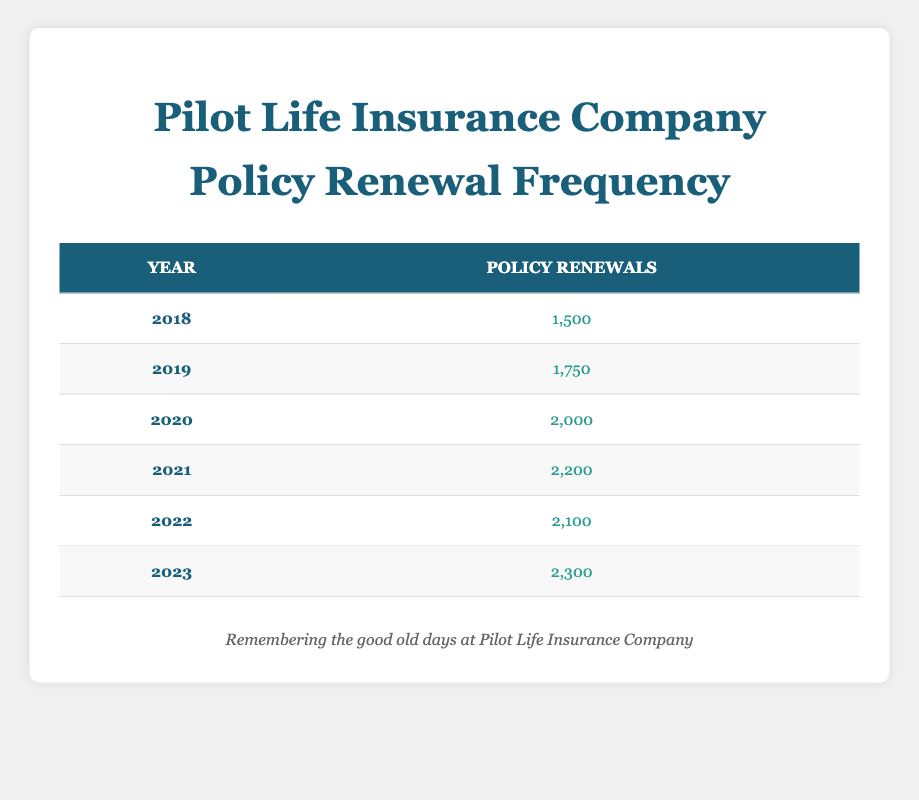What is the total number of policy renewals from 2018 to 2023? To find the total number of policy renewals, we sum the renewal counts for each year. The calculation is: 1500 + 1750 + 2000 + 2200 + 2100 + 2300 = 11850.
Answer: 11850 Which year had the highest number of policy renewals? From the table, the year with the highest renewal count is 2023, with 2300 renewals.
Answer: 2023 Was there an increase in policy renewals from 2021 to 2022? The renewal count for 2021 is 2200, and for 2022 it's 2100. Since 2100 is less than 2200, there was a decrease.
Answer: No What is the average number of policy renewals per year from 2019 to 2021? The renewal counts for the years 2019, 2020, and 2021 are 1750, 2000, and 2200, respectively. To find the average, we sum these values (1750 + 2000 + 2200 = 5950) and then divide by 3, resulting in an average of 5950 / 3 ≈ 1983.33.
Answer: Approximately 1983.33 Did policy renewals in 2022 exceed those in 2019? The renewal count for 2022 is 2100, and for 2019 it is 1750. Since 2100 is greater than 1750, the statement is true.
Answer: Yes What was the change in policy renewals from 2020 to 2021? The renewal count for 2020 is 2000, and for 2021 it is 2200. To find the change, we subtract 2000 from 2200, resulting in an increase of 200.
Answer: 200 How many more policies were renewed in 2023 compared to 2021? The renewal count in 2023 is 2300, and in 2021 it is 2200. The difference is 2300 - 2200 = 100, indicating that there were 100 more renewals in 2023 compared to 2021.
Answer: 100 Which year had the least number of policy renewals? By examining the renewal counts, 2018 had the least with 1500 renewals.
Answer: 2018 